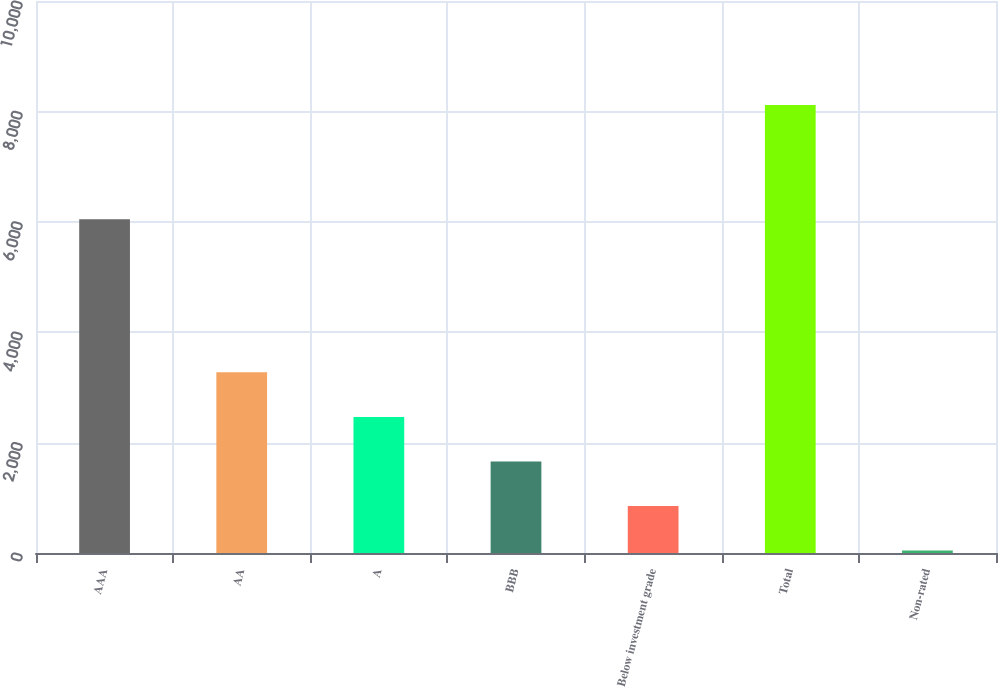<chart> <loc_0><loc_0><loc_500><loc_500><bar_chart><fcel>AAA<fcel>AA<fcel>A<fcel>BBB<fcel>Below investment grade<fcel>Total<fcel>Non-rated<nl><fcel>6047<fcel>3272.8<fcel>2465.6<fcel>1658.4<fcel>851.2<fcel>8116<fcel>44<nl></chart> 